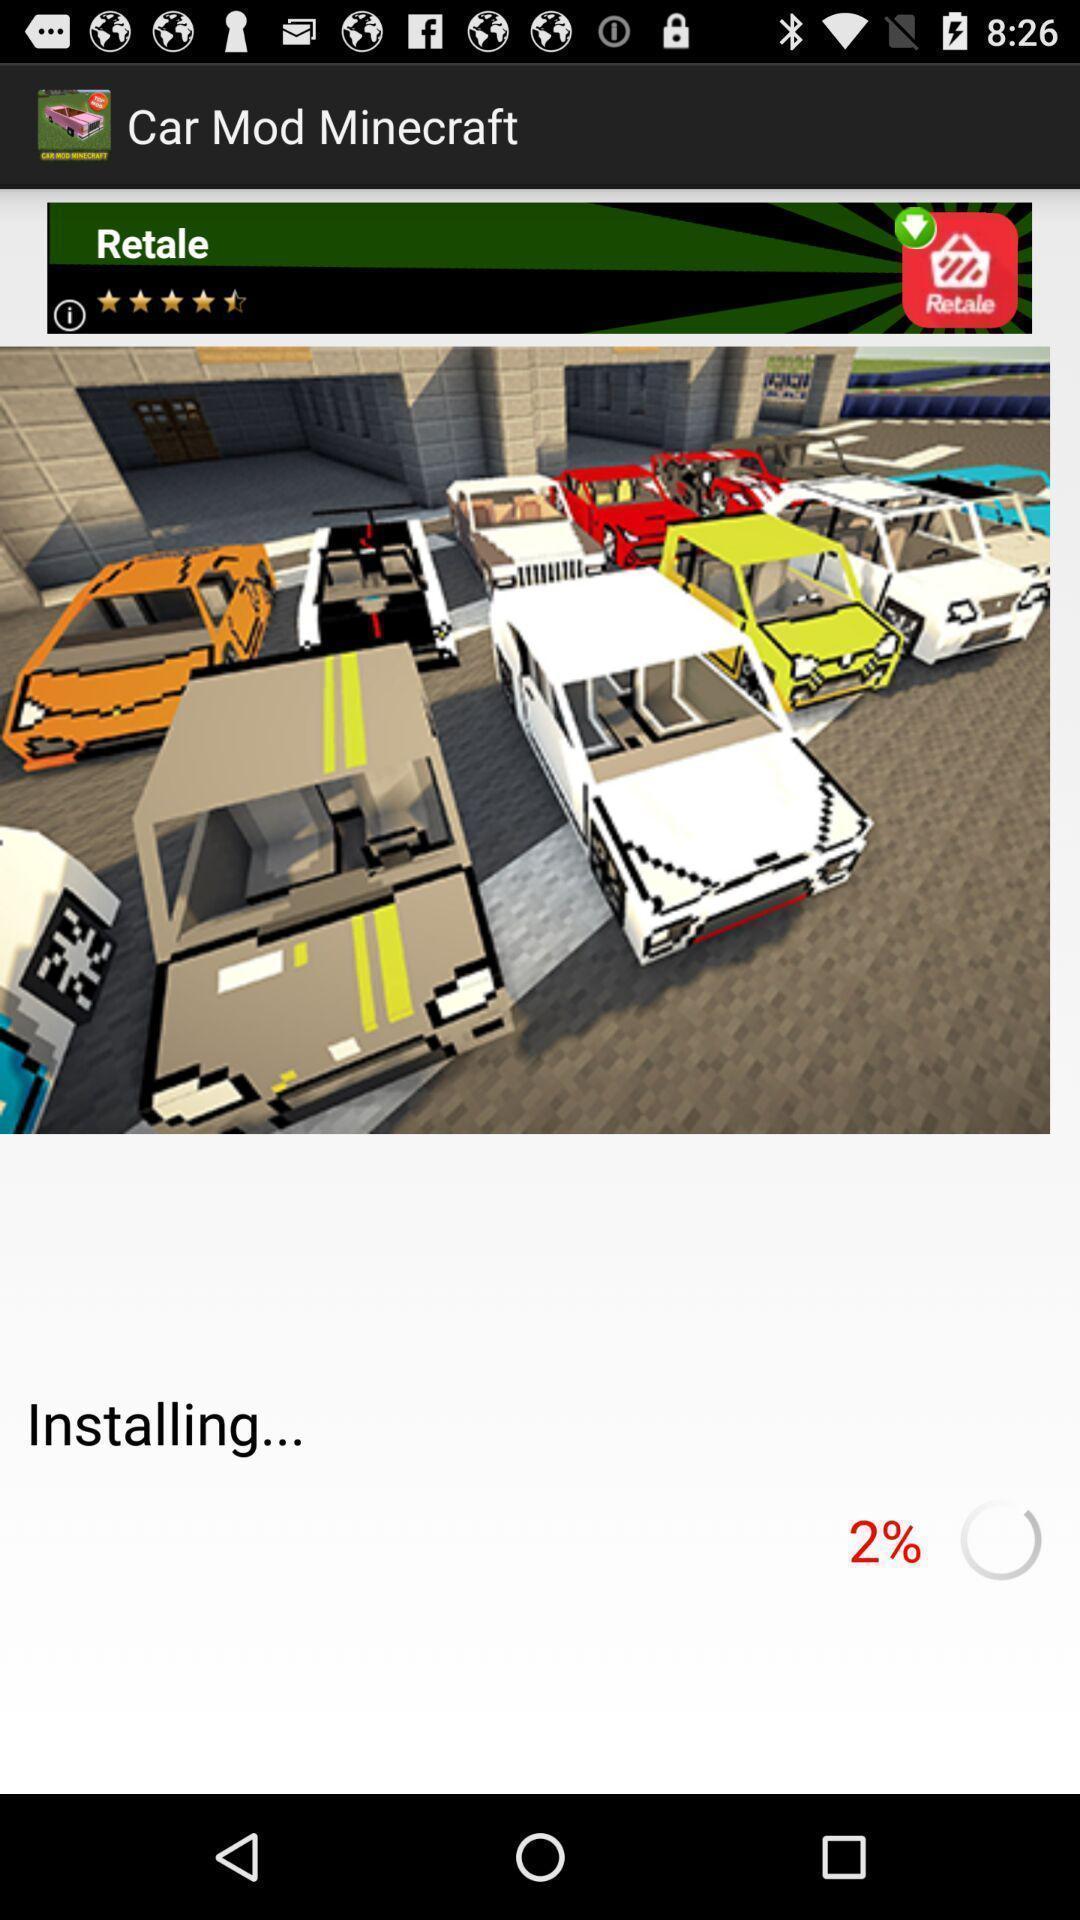Give me a summary of this screen capture. Page displaying installing percentage. 